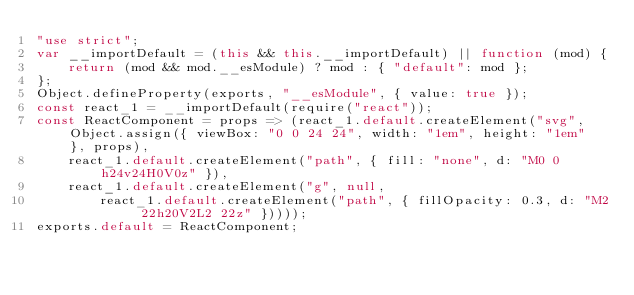Convert code to text. <code><loc_0><loc_0><loc_500><loc_500><_JavaScript_>"use strict";
var __importDefault = (this && this.__importDefault) || function (mod) {
    return (mod && mod.__esModule) ? mod : { "default": mod };
};
Object.defineProperty(exports, "__esModule", { value: true });
const react_1 = __importDefault(require("react"));
const ReactComponent = props => (react_1.default.createElement("svg", Object.assign({ viewBox: "0 0 24 24", width: "1em", height: "1em" }, props),
    react_1.default.createElement("path", { fill: "none", d: "M0 0h24v24H0V0z" }),
    react_1.default.createElement("g", null,
        react_1.default.createElement("path", { fillOpacity: 0.3, d: "M2 22h20V2L2 22z" }))));
exports.default = ReactComponent;
</code> 